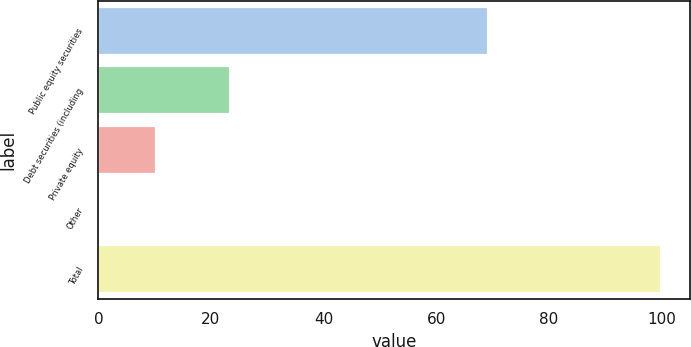<chart> <loc_0><loc_0><loc_500><loc_500><bar_chart><fcel>Public equity securities<fcel>Debt securities (including<fcel>Private equity<fcel>Other<fcel>Total<nl><fcel>69.2<fcel>23.3<fcel>10.27<fcel>0.3<fcel>100<nl></chart> 